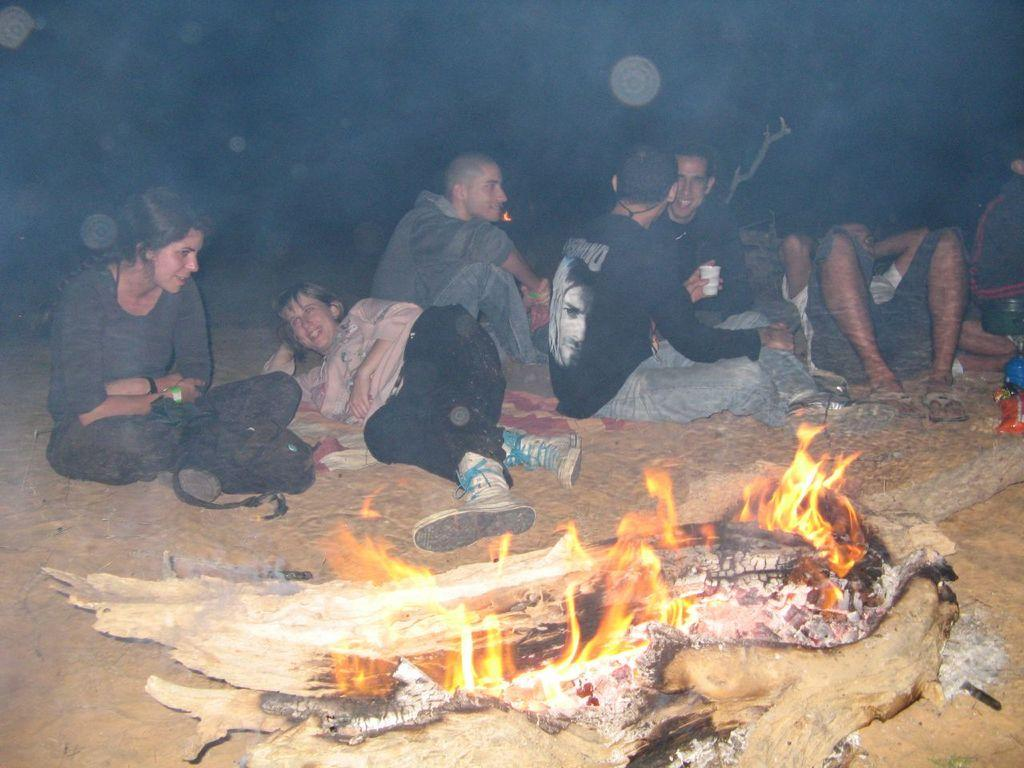What are the people in the image doing? The people in the image are lying and sitting on the surface. What can be seen in front of the people? There are objects in front of the people, including a burning wooden log. What is visible in the background of the image? There is a branch of a tree visible in the background of the image. How does the mountain in the image affect the temperature? There is no mountain present in the image, so it cannot affect the temperature. 